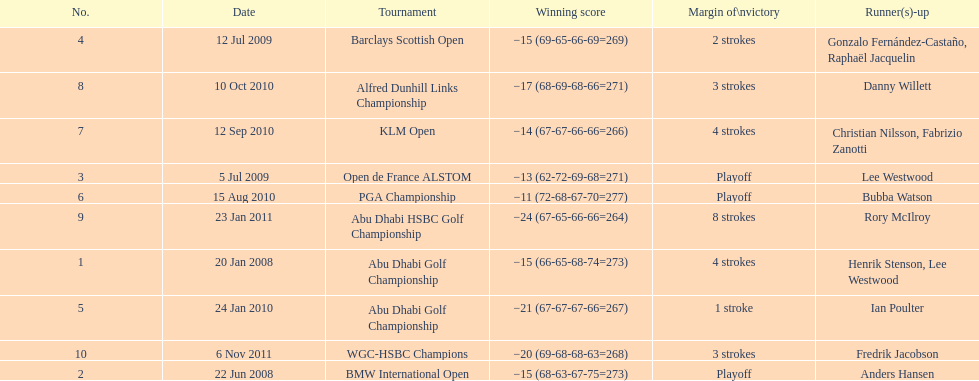Who had the top score in the pga championship? Bubba Watson. 